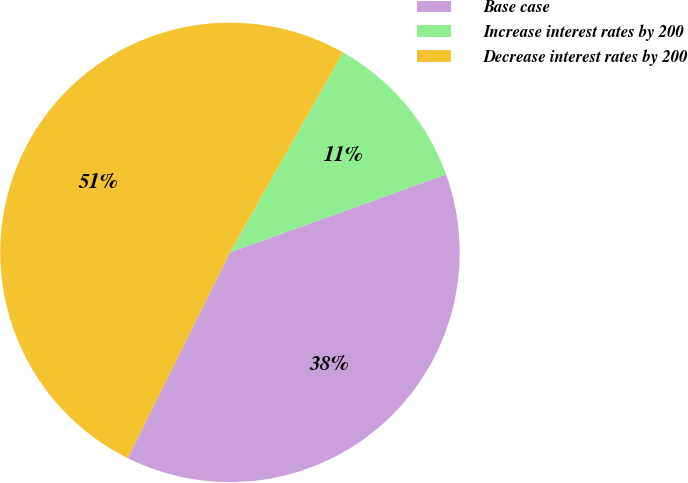Convert chart. <chart><loc_0><loc_0><loc_500><loc_500><pie_chart><fcel>Base case<fcel>Increase interest rates by 200<fcel>Decrease interest rates by 200<nl><fcel>37.85%<fcel>11.3%<fcel>50.85%<nl></chart> 